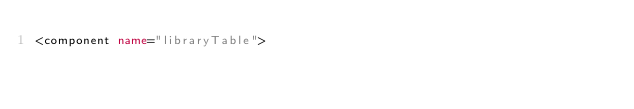<code> <loc_0><loc_0><loc_500><loc_500><_XML_><component name="libraryTable"></code> 